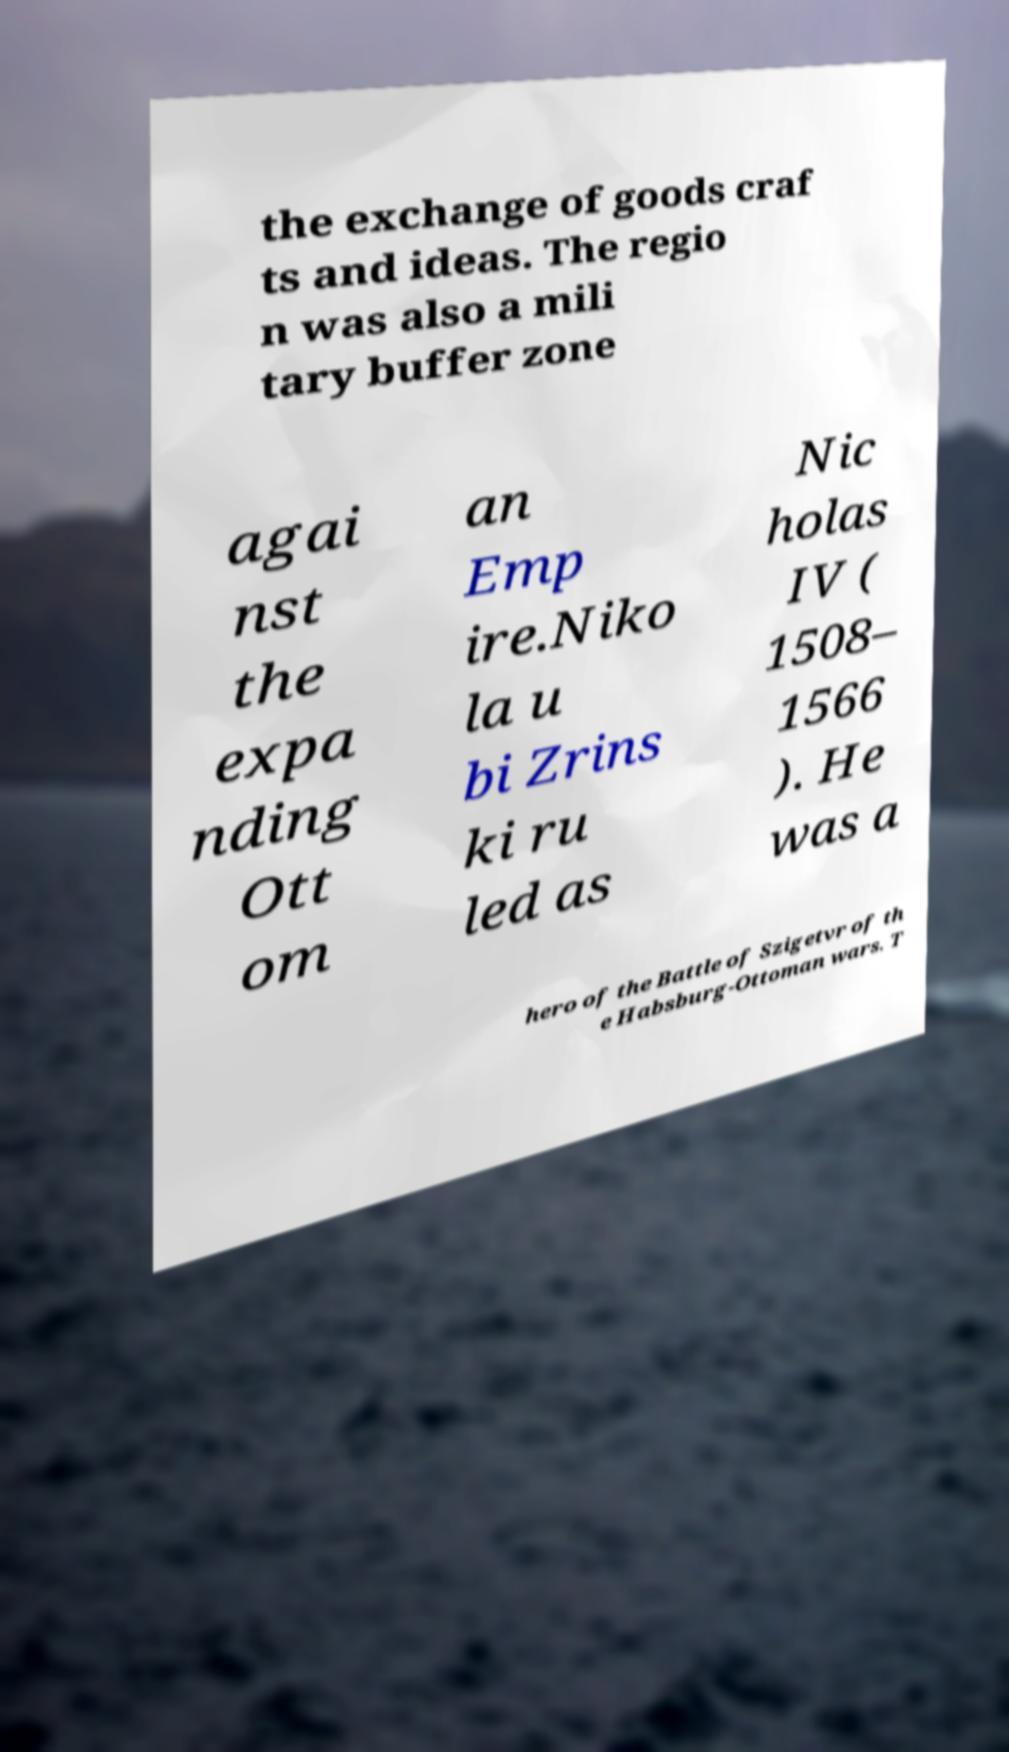For documentation purposes, I need the text within this image transcribed. Could you provide that? the exchange of goods craf ts and ideas. The regio n was also a mili tary buffer zone agai nst the expa nding Ott om an Emp ire.Niko la u bi Zrins ki ru led as Nic holas IV ( 1508– 1566 ). He was a hero of the Battle of Szigetvr of th e Habsburg-Ottoman wars. T 